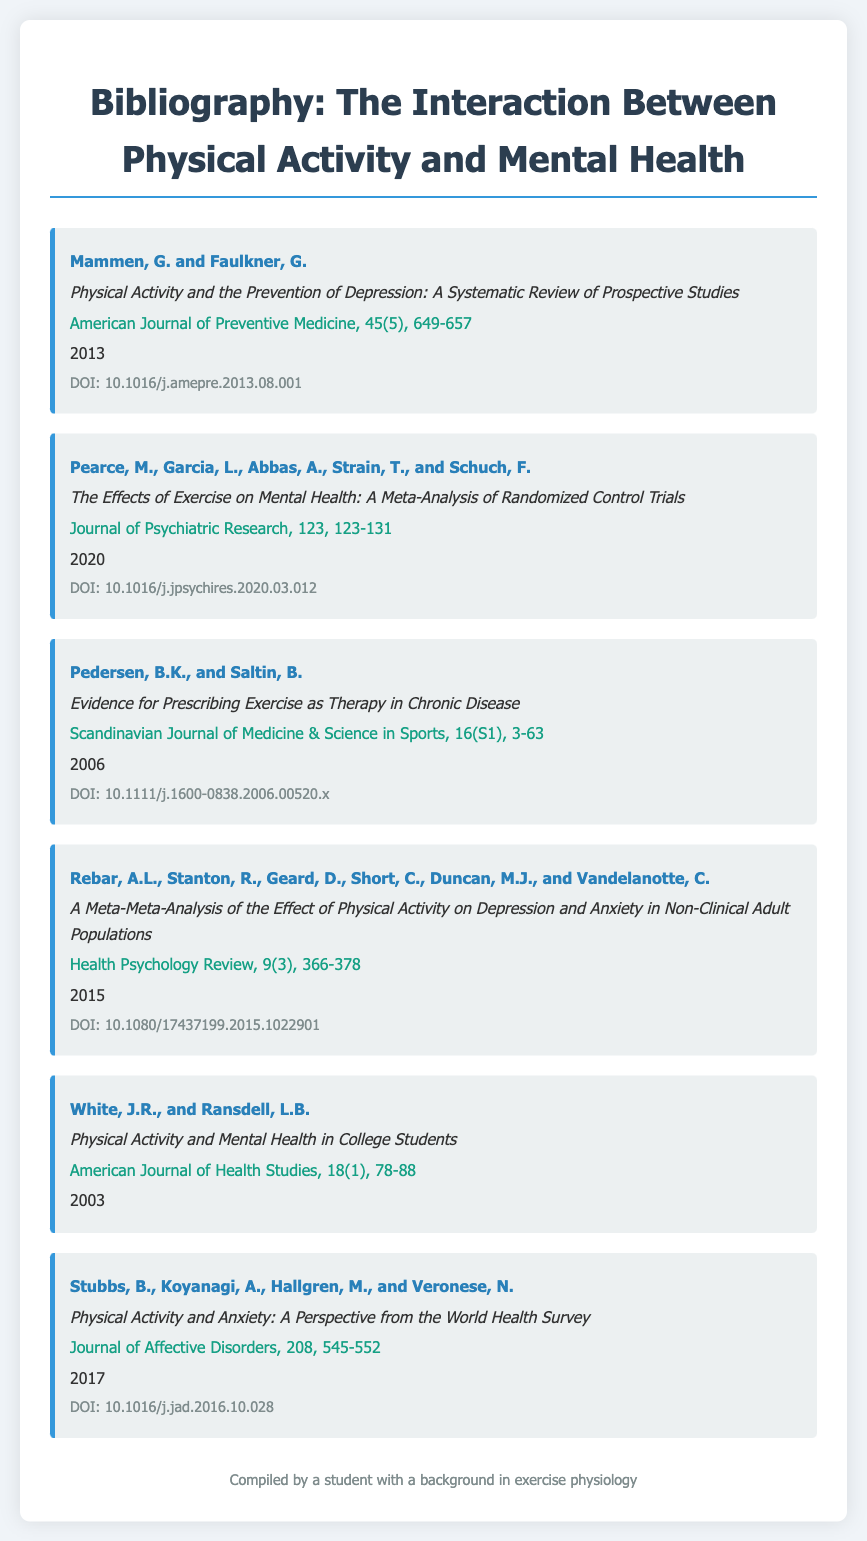what is the title of the first article in the bibliography? The title of the first article is listed at the beginning of its respective entry.
Answer: Physical Activity and the Prevention of Depression: A Systematic Review of Prospective Studies who are the authors of the meta-analysis published in 2020? The authors of the 2020 meta-analysis are listed under the respective entry.
Answer: Pearce, M., Garcia, L., Abbas, A., Strain, T., and Schuch, F what is the journal name for the article authored by Rebar et al.? The journal name is found in the details provided for each article.
Answer: Health Psychology Review in which year was the article about physical activity and mental health in college students published? The publication year is specified at the end of each article entry.
Answer: 2003 how many articles include a DOI in their details? The presence of a DOI can be counted from the respective entries that include it.
Answer: 5 what is the volume number of the Journal of Affective Disorders where Stubbs et al.'s article is published? The volume number is found in the citation of the journal article.
Answer: 208 which author in the bibliography has the greatest number of contributions listed? The authors are listed in multiple articles; we need to count their occurrences across the entries.
Answer: Multiple authors have one contribution each, but specific individual contributions are needed for precise comparison what is the unique aspect of the document type specified in the title? The title indicates that this document is focused specifically on a collection of references related to a systematic review.
Answer: Bibliography 